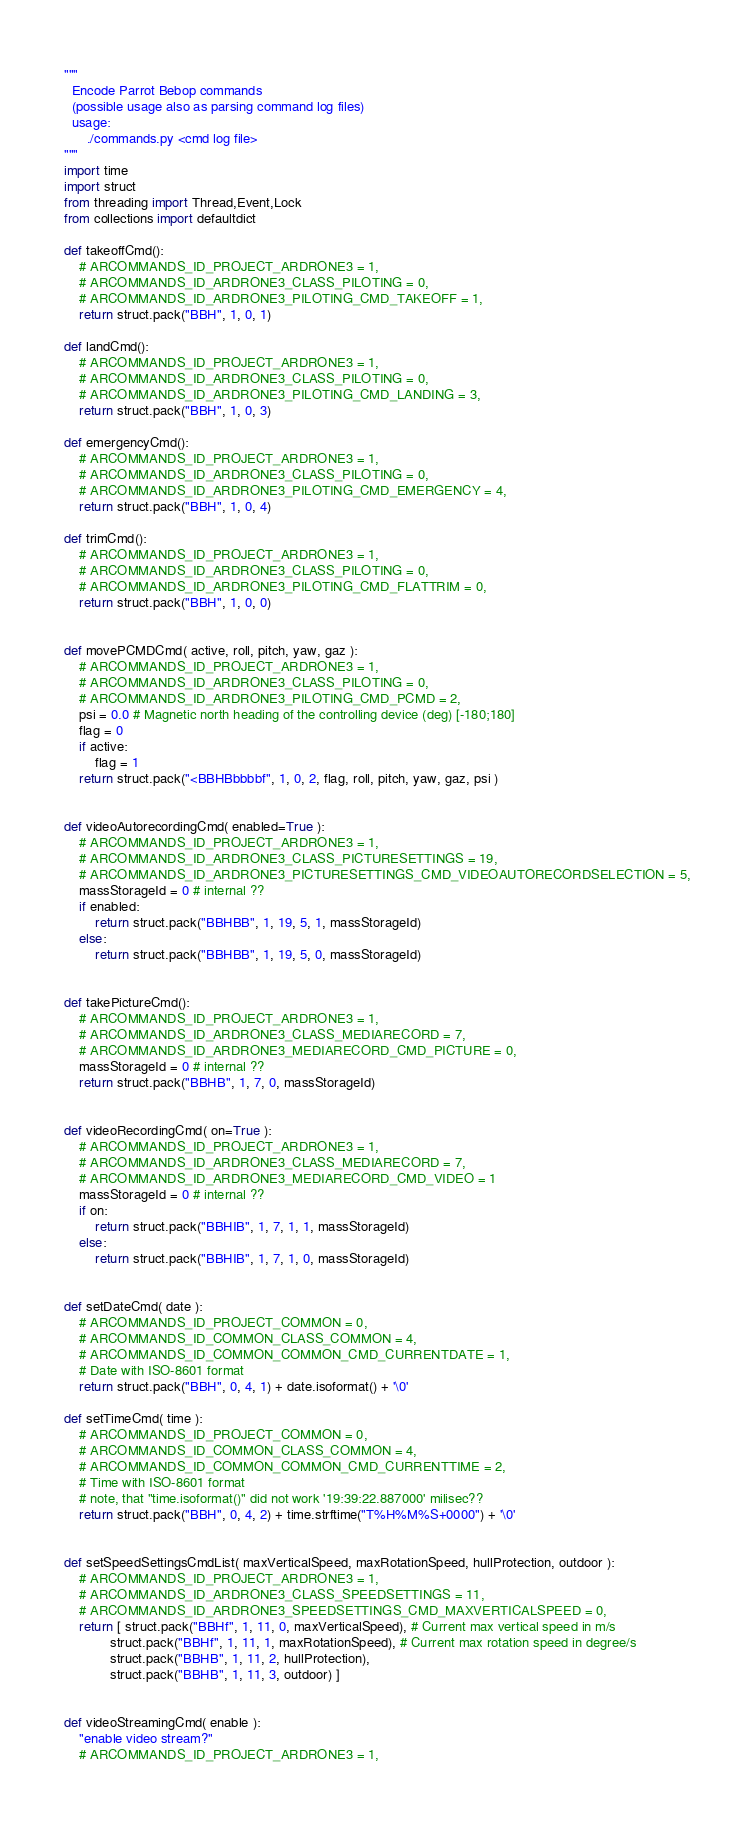<code> <loc_0><loc_0><loc_500><loc_500><_Python_>"""
  Encode Parrot Bebop commands
  (possible usage also as parsing command log files)
  usage:
      ./commands.py <cmd log file>
"""
import time
import struct
from threading import Thread,Event,Lock
from collections import defaultdict

def takeoffCmd():
    # ARCOMMANDS_ID_PROJECT_ARDRONE3 = 1,
    # ARCOMMANDS_ID_ARDRONE3_CLASS_PILOTING = 0,
    # ARCOMMANDS_ID_ARDRONE3_PILOTING_CMD_TAKEOFF = 1,
    return struct.pack("BBH", 1, 0, 1)
      
def landCmd():
    # ARCOMMANDS_ID_PROJECT_ARDRONE3 = 1,
    # ARCOMMANDS_ID_ARDRONE3_CLASS_PILOTING = 0,
    # ARCOMMANDS_ID_ARDRONE3_PILOTING_CMD_LANDING = 3,
    return struct.pack("BBH", 1, 0, 3)

def emergencyCmd():
    # ARCOMMANDS_ID_PROJECT_ARDRONE3 = 1,
    # ARCOMMANDS_ID_ARDRONE3_CLASS_PILOTING = 0,
    # ARCOMMANDS_ID_ARDRONE3_PILOTING_CMD_EMERGENCY = 4,
    return struct.pack("BBH", 1, 0, 4)

def trimCmd():
    # ARCOMMANDS_ID_PROJECT_ARDRONE3 = 1,
    # ARCOMMANDS_ID_ARDRONE3_CLASS_PILOTING = 0,
    # ARCOMMANDS_ID_ARDRONE3_PILOTING_CMD_FLATTRIM = 0,
    return struct.pack("BBH", 1, 0, 0)


def movePCMDCmd( active, roll, pitch, yaw, gaz ):
    # ARCOMMANDS_ID_PROJECT_ARDRONE3 = 1,
    # ARCOMMANDS_ID_ARDRONE3_CLASS_PILOTING = 0,
    # ARCOMMANDS_ID_ARDRONE3_PILOTING_CMD_PCMD = 2,
    psi = 0.0 # Magnetic north heading of the controlling device (deg) [-180;180]
    flag = 0
    if active:
        flag = 1
    return struct.pack("<BBHBbbbbf", 1, 0, 2, flag, roll, pitch, yaw, gaz, psi )


def videoAutorecordingCmd( enabled=True ):
    # ARCOMMANDS_ID_PROJECT_ARDRONE3 = 1,
    # ARCOMMANDS_ID_ARDRONE3_CLASS_PICTURESETTINGS = 19,    
    # ARCOMMANDS_ID_ARDRONE3_PICTURESETTINGS_CMD_VIDEOAUTORECORDSELECTION = 5,
    massStorageId = 0 # internal ??
    if enabled:
        return struct.pack("BBHBB", 1, 19, 5, 1, massStorageId)
    else:
        return struct.pack("BBHBB", 1, 19, 5, 0, massStorageId)


def takePictureCmd():
    # ARCOMMANDS_ID_PROJECT_ARDRONE3 = 1,
    # ARCOMMANDS_ID_ARDRONE3_CLASS_MEDIARECORD = 7,
    # ARCOMMANDS_ID_ARDRONE3_MEDIARECORD_CMD_PICTURE = 0,
    massStorageId = 0 # internal ??
    return struct.pack("BBHB", 1, 7, 0, massStorageId)


def videoRecordingCmd( on=True ):
    # ARCOMMANDS_ID_PROJECT_ARDRONE3 = 1,
    # ARCOMMANDS_ID_ARDRONE3_CLASS_MEDIARECORD = 7,
    # ARCOMMANDS_ID_ARDRONE3_MEDIARECORD_CMD_VIDEO = 1
    massStorageId = 0 # internal ??
    if on:
        return struct.pack("BBHIB", 1, 7, 1, 1, massStorageId)
    else:
        return struct.pack("BBHIB", 1, 7, 1, 0, massStorageId)


def setDateCmd( date ):
    # ARCOMMANDS_ID_PROJECT_COMMON = 0,
    # ARCOMMANDS_ID_COMMON_CLASS_COMMON = 4,
    # ARCOMMANDS_ID_COMMON_COMMON_CMD_CURRENTDATE = 1,
    # Date with ISO-8601 format
    return struct.pack("BBH", 0, 4, 1) + date.isoformat() + '\0'

def setTimeCmd( time ):    
    # ARCOMMANDS_ID_PROJECT_COMMON = 0,
    # ARCOMMANDS_ID_COMMON_CLASS_COMMON = 4,
    # ARCOMMANDS_ID_COMMON_COMMON_CMD_CURRENTTIME = 2,
    # Time with ISO-8601 format
    # note, that "time.isoformat()" did not work '19:39:22.887000' milisec??
    return struct.pack("BBH", 0, 4, 2) + time.strftime("T%H%M%S+0000") + '\0'


def setSpeedSettingsCmdList( maxVerticalSpeed, maxRotationSpeed, hullProtection, outdoor ):
    # ARCOMMANDS_ID_PROJECT_ARDRONE3 = 1,
    # ARCOMMANDS_ID_ARDRONE3_CLASS_SPEEDSETTINGS = 11,
    # ARCOMMANDS_ID_ARDRONE3_SPEEDSETTINGS_CMD_MAXVERTICALSPEED = 0,
    return [ struct.pack("BBHf", 1, 11, 0, maxVerticalSpeed), # Current max vertical speed in m/s
            struct.pack("BBHf", 1, 11, 1, maxRotationSpeed), # Current max rotation speed in degree/s
            struct.pack("BBHB", 1, 11, 2, hullProtection),
            struct.pack("BBHB", 1, 11, 3, outdoor) ]


def videoStreamingCmd( enable ):
    "enable video stream?"
    # ARCOMMANDS_ID_PROJECT_ARDRONE3 = 1,</code> 